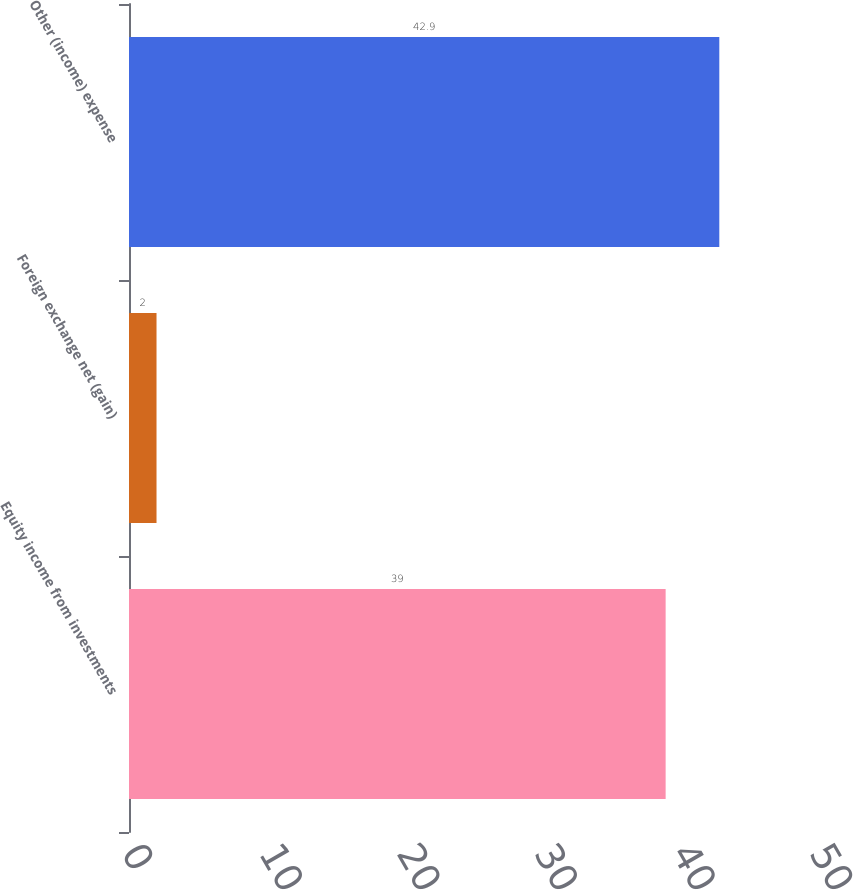Convert chart to OTSL. <chart><loc_0><loc_0><loc_500><loc_500><bar_chart><fcel>Equity income from investments<fcel>Foreign exchange net (gain)<fcel>Other (income) expense<nl><fcel>39<fcel>2<fcel>42.9<nl></chart> 